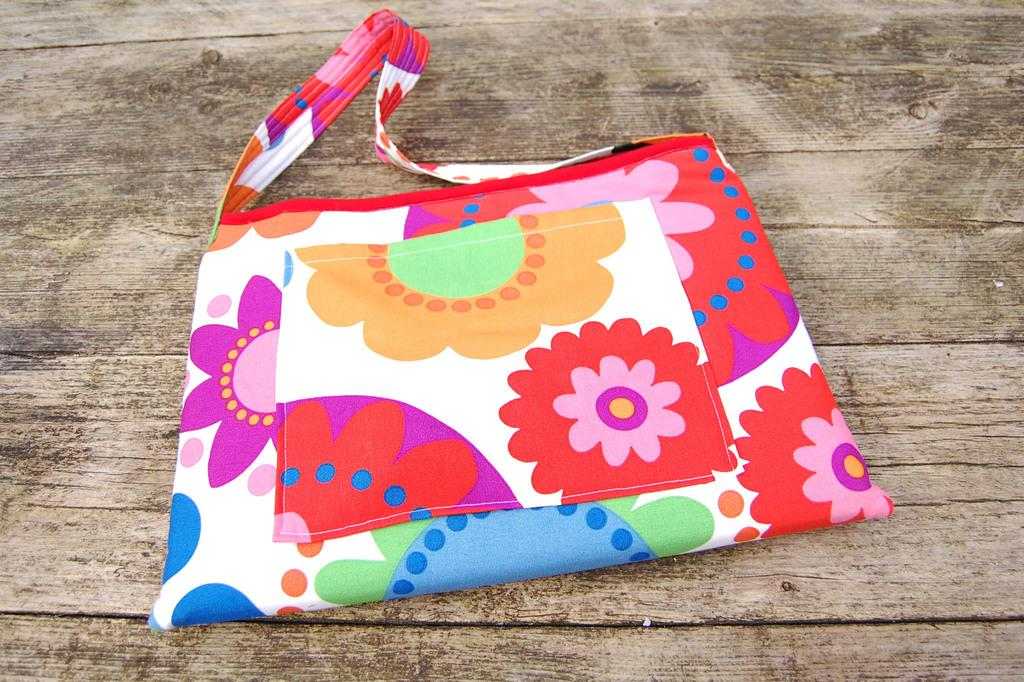What object is present in the image? There is a handbag in the image. Can you describe the appearance of the handbag? The handbag has colorful prints on it. What type of voice can be heard coming from the handbag in the image? There is no voice coming from the handbag in the image, as it is an inanimate object. 